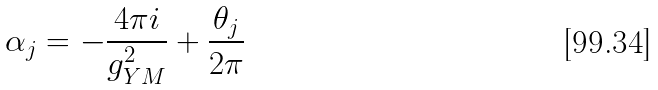<formula> <loc_0><loc_0><loc_500><loc_500>\alpha _ { j } = - \frac { 4 \pi i } { g _ { Y M } ^ { 2 } } + \frac { \theta _ { j } } { 2 \pi }</formula> 